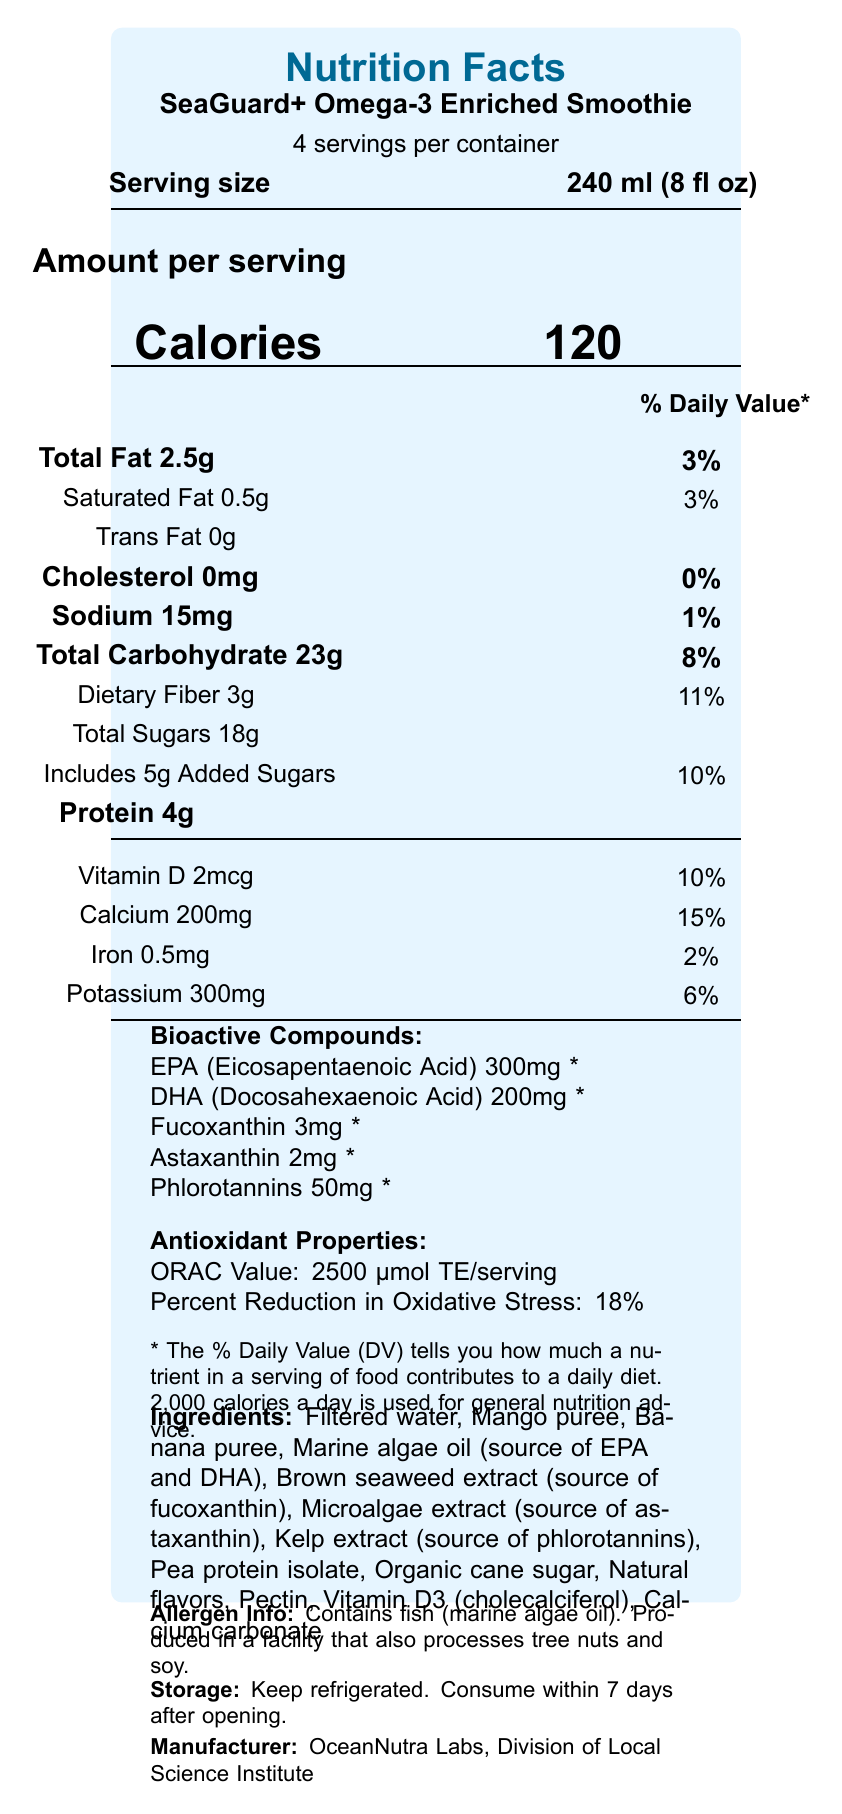what is the serving size? The serving size is explicitly stated as "240 ml (8 fl oz)" in the document.
Answer: 240 ml (8 fl oz) how many calories are in one serving of the SeaGuard+ Omega-3 Enriched Smoothie? The amount of calories per serving is clearly mentioned as "120" in the document.
Answer: 120 what is the total fat content per serving? The document lists "Total Fat 2.5g" under the Amount per serving section.
Answer: 2.5 grams how much dietary fiber is there per serving, and what percentage of the Daily Value does this represent? The document states "Dietary Fiber 3g" and "11%" for the Daily Value.
Answer: 3 grams, 11% list all bioactive compounds included in the product. The document provides a section labeled "Bioactive Compounds" and lists all these under it.
Answer: EPA (Eicosapentaenoic Acid), DHA (Docosahexaenoic Acid), Fucoxanthin, Astaxanthin, Phlorotannins which vitamin contributes 10% to the Daily Value? A. Vitamin C B. Vitamin D C. Vitamin A D. Vitamin E The document notes "Vitamin D 2mcg 10%" indicating that Vitamin D contributes 10% to the Daily Value.
Answer: B. Vitamin D what is the total amount of sugars per serving, and how many grams are added sugars? The document provides this information under "Total Sugars 18g" and "Includes 5g Added Sugars".
Answer: Total sugars: 18g, Added sugars: 5g which ingredient is a source of both EPA and DHA? A. Mango puree B. Marine algae oil C. Brown seaweed extract D. Microalgae extract The document indicates that "Marine algae oil" is a source of EPA and DHA.
Answer: B. Marine algae oil is there any cholesterol in the SeaGuard+ Omega-3 Enriched Smoothie? The document lists "Cholesterol 0mg" indicating no cholesterol per serving.
Answer: No does the document mention how the product should be stored? The "Storage: Keep refrigerated. Consume within 7 days after opening." section provides storage instructions.
Answer: Yes how much calcium does one serving provide and what percent of Daily Value is this? The document mentions "Calcium 200mg" and a Daily Value of 15%.
Answer: 200 mg, 15% what is an ingredient that could trigger an allergy for some people? The "Allergen Info" section mentions "Contains fish (marine algae oil)".
Answer: Fish (marine algae oil) what are the antioxidant properties of the SeaGuard+ Omega-3 Enriched Smoothie? The antioxidant properties are listed as "ORAC Value: 2500 μmol TE/serving" and "Percent Reduction in Oxidative Stress: 18%".
Answer: ORAC Value: 2500 μmol TE/serving, Percent Reduction in Oxidative Stress: 18% what company manufactures the SeaGuard+ Omega-3 Enriched Smoothie? The bottom of the document lists the manufacturer as "OceanNutra Labs, Division of Local Science Institute".
Answer: OceanNutra Labs, Division of Local Science Institute summarize the main idea of the document. The document provides comprehensive information on the nutritional content and specific functional ingredients of SeaGuard+ Omega-3 Enriched Smoothie, emphasizing its bioactive compounds from marine organisms.
Answer: The document is a detailed nutrition facts label for SeaGuard+ Omega-3 Enriched Smoothie, highlighting its serving size, calories, macronutrient breakdown, vitamins and minerals, bioactive compounds, antioxidant properties, ingredients, allergen information, storage instructions, and manufacturer details. what percentage of the daily value of iron does one serving provide? The document states "Iron 0.5mg" and "2%" under the Daily Value.
Answer: 2% what is the ORAC value per serving? The document lists this specific antioxidant property under the "Antioxidant Properties" section.
Answer: 2500 μmol TE/serving does the document provide the shelf life of the product without refrigeration? The document only provides storage instructions that specify keeping the product refrigerated and consuming it within 7 days after opening.
Answer: Cannot be determined 